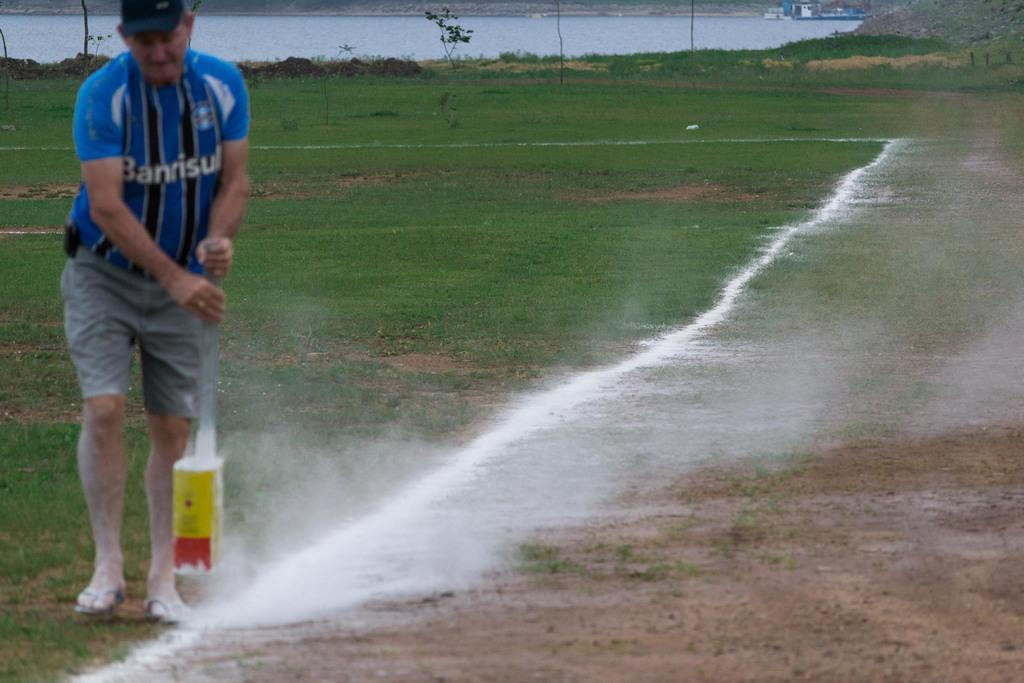<image>
Relay a brief, clear account of the picture shown. A man in a blue Banrisul jersey chalking a line. 